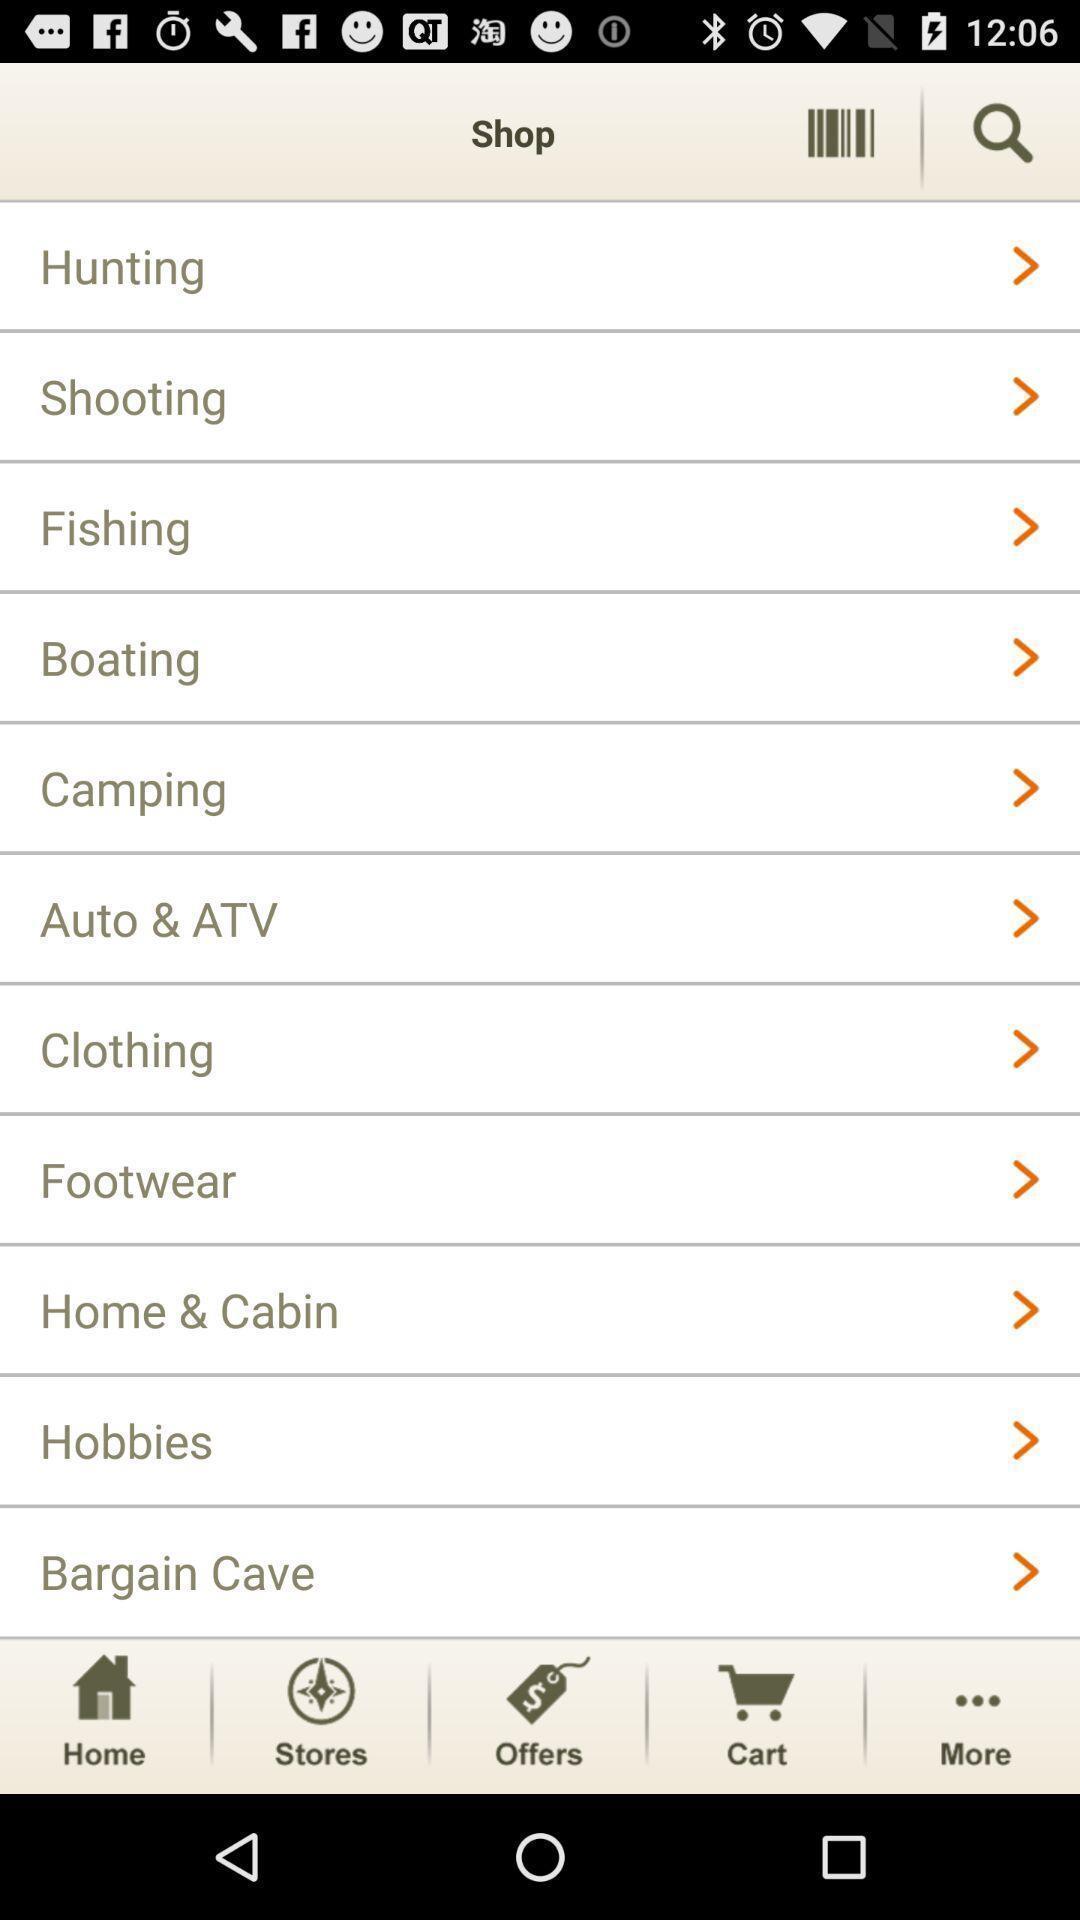What is the overall content of this screenshot? Page shows an ecommerce website. 